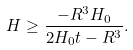<formula> <loc_0><loc_0><loc_500><loc_500>H \geq \frac { - R ^ { 3 } H _ { 0 } } { 2 H _ { 0 } t - R ^ { 3 } } .</formula> 